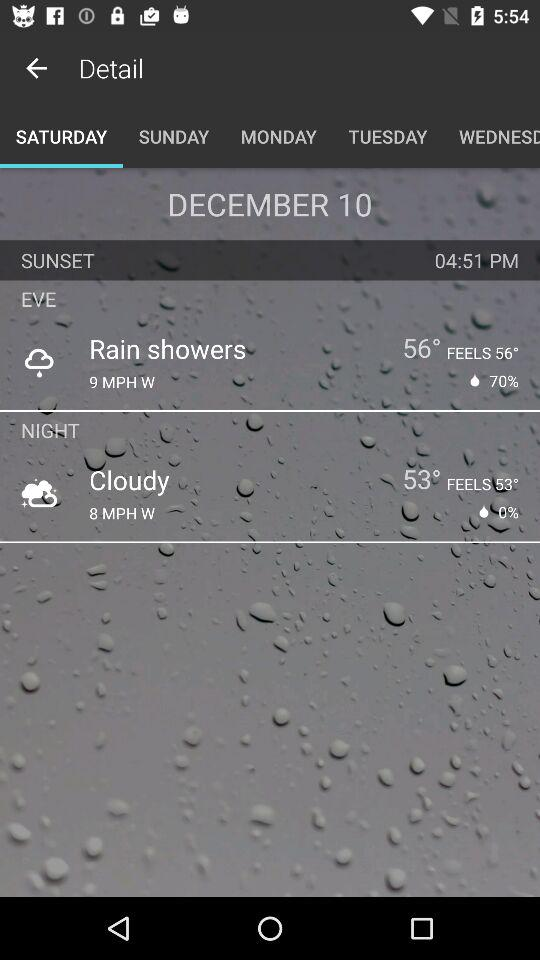Which tab am I on? You are on the "SATURDAY" tab. 